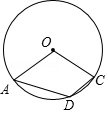Given: In the diagram, point O is the center of circle O, and point D lies on circle O. If the measure of angle AOC is x, what is the degree of angle ADC? To determine the measure of angle ADC, we must apply the inscribed angle theorem, which states that the inscribed angle is half the measure of the central angle that subtends the same arc. Since angle AOC is a central angle measuring x degrees and ADC is an inscribed angle that subtends the same arc AC, the measure of angle ADC is x/2. Therefore, if the measure of angle AOC is x, then the measure of angle ADC is indeed x/2. Without the specific value for x, we cannot select one of the choices provided. 